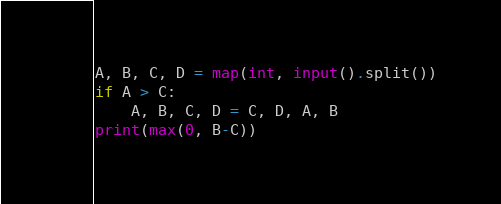<code> <loc_0><loc_0><loc_500><loc_500><_Python_>A, B, C, D = map(int, input().split())
if A > C:
    A, B, C, D = C, D, A, B
print(max(0, B-C))</code> 